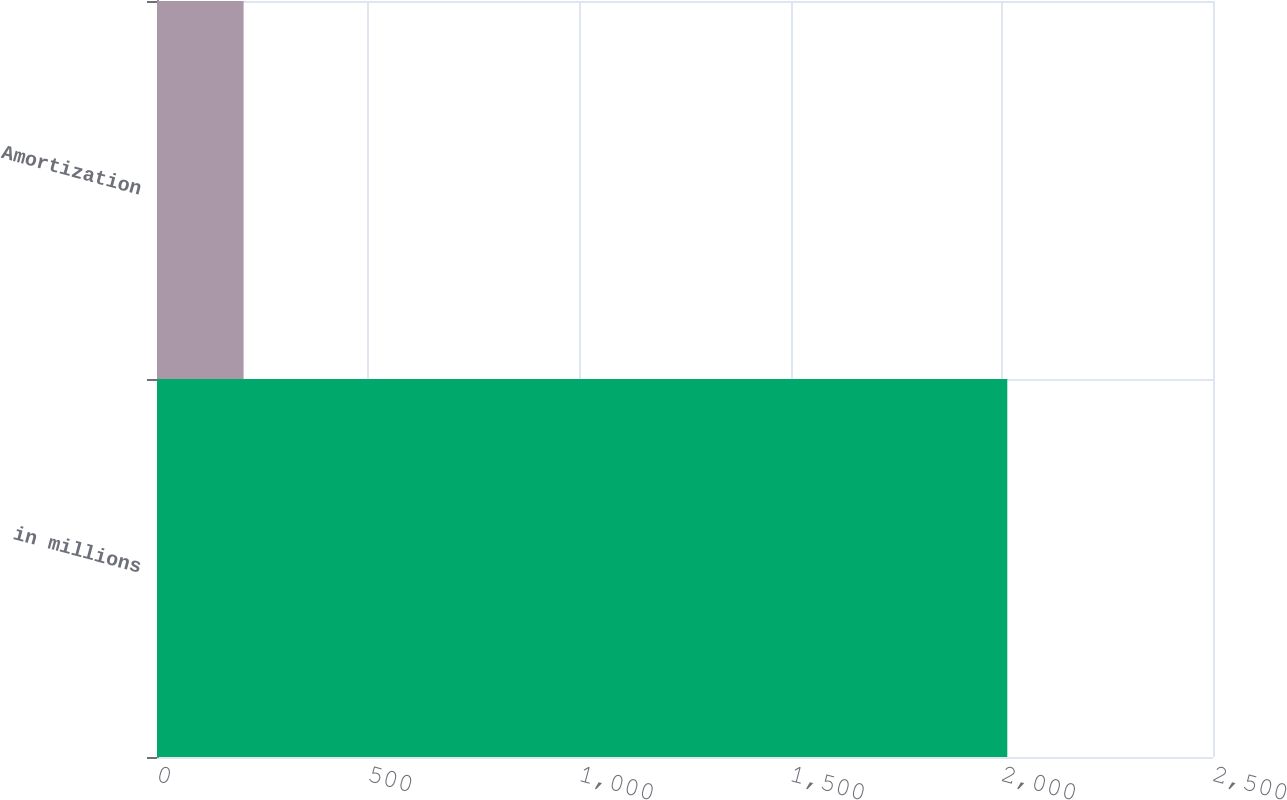Convert chart to OTSL. <chart><loc_0><loc_0><loc_500><loc_500><bar_chart><fcel>in millions<fcel>Amortization<nl><fcel>2013<fcel>205<nl></chart> 